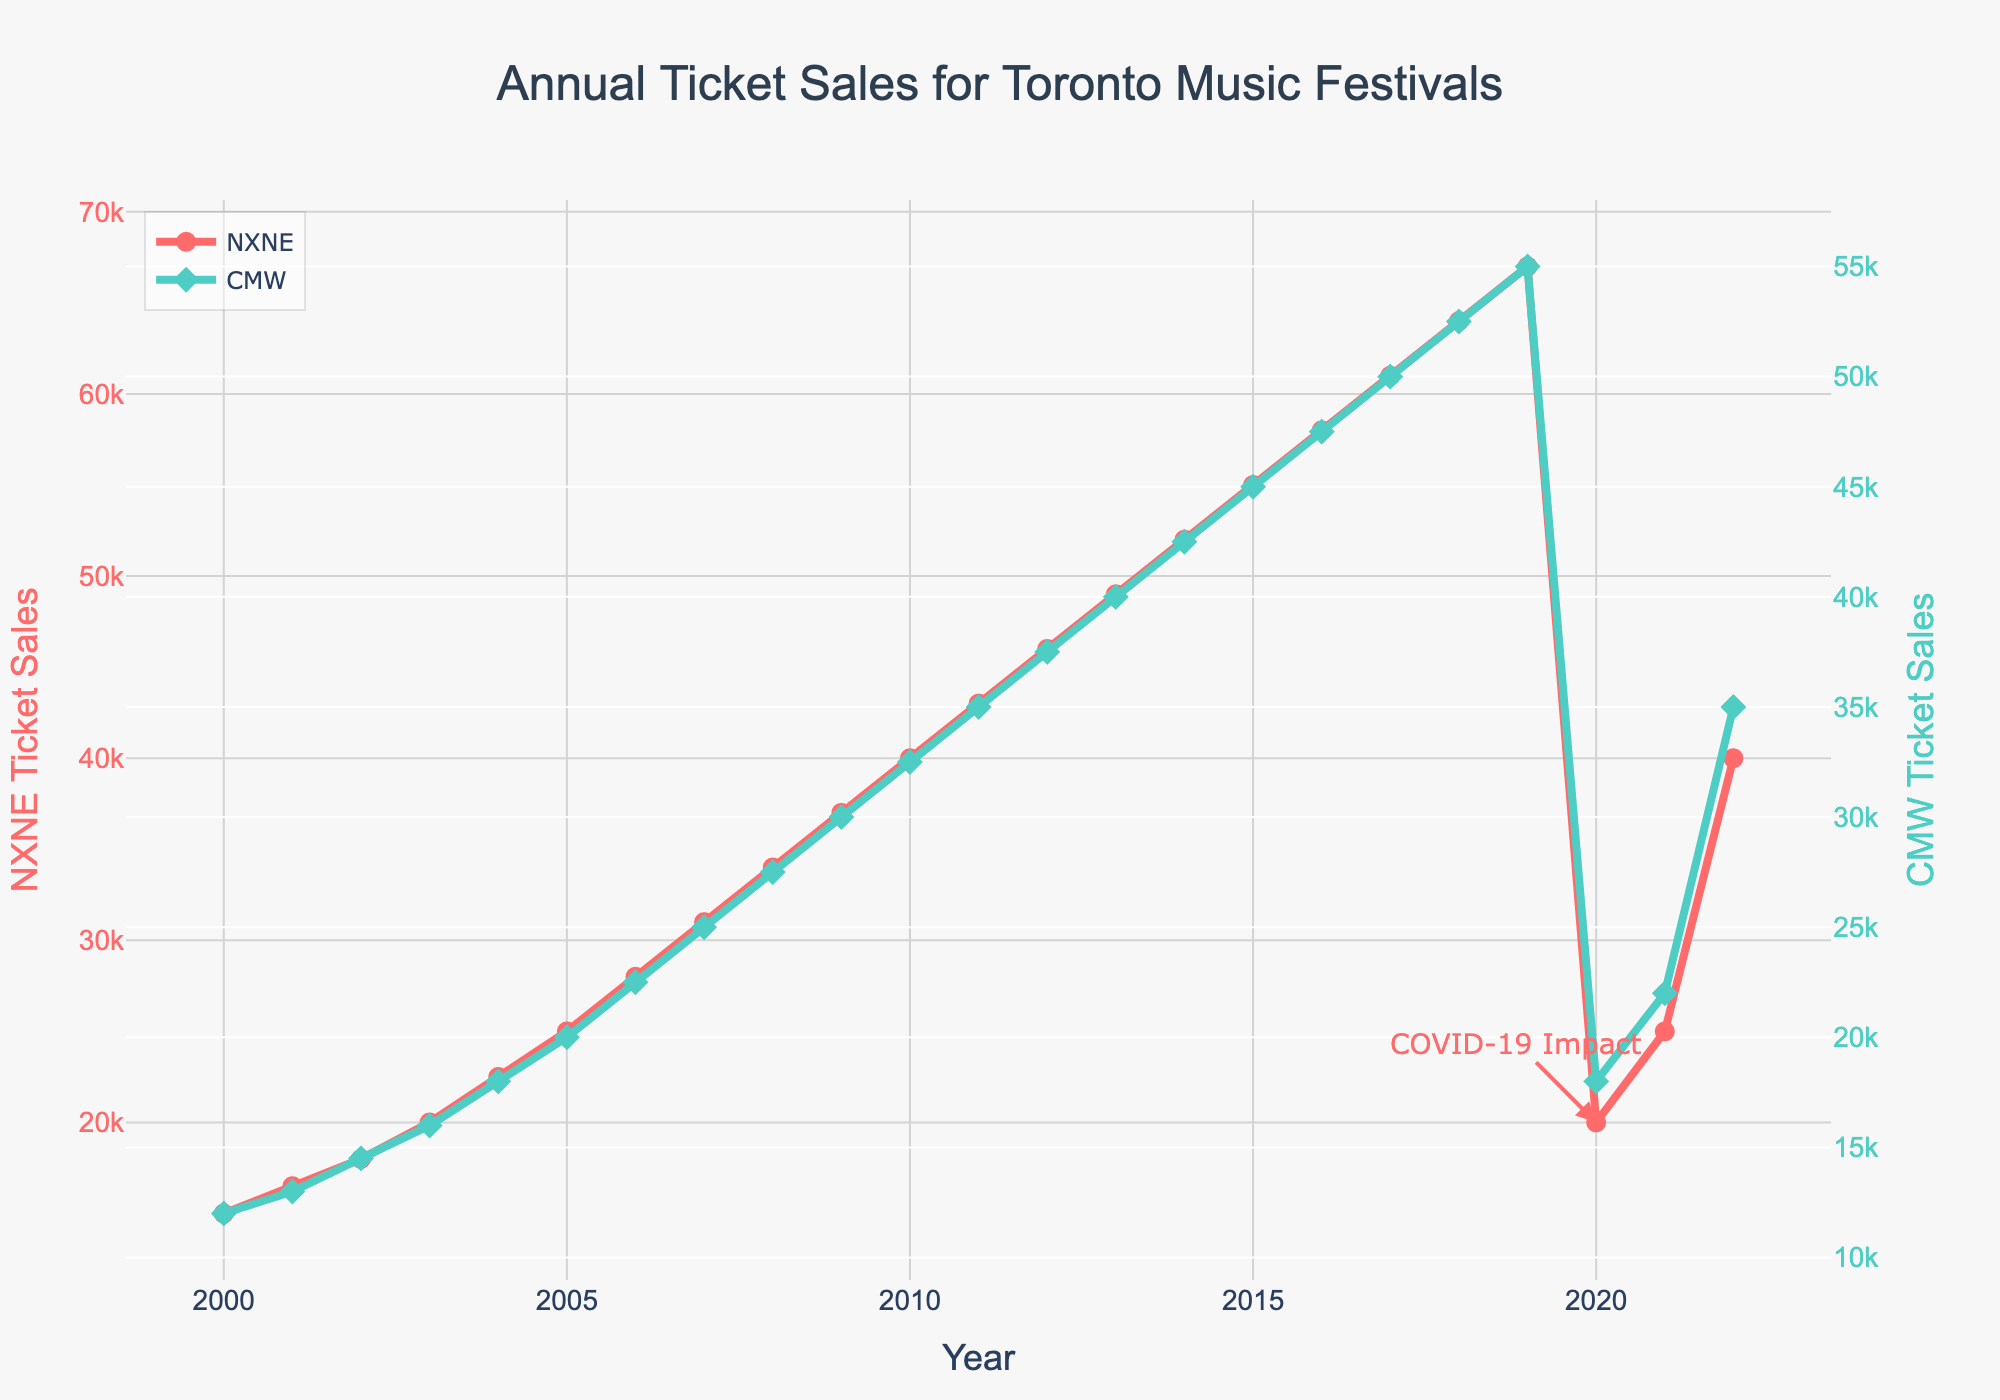Which year had the highest ticket sales for NXNE? Looking at the line representing NXNE ticket sales, the highest point on the graph corresponds to the year 2019.
Answer: 2019 What were the ticket sales for CMW in 2014? By checking the point on the CMW line that corresponds to the year 2014, we see it reaches 42,500 ticket sales.
Answer: 42,500 How did ticket sales for NXNE change between 2019 and 2020? The plot shows a steep decline from the highest point in 2019 (67,000) to a sharp drop in 2020 (20,000). Subtract 20,000 from 67,000 to find the change.
Answer: -47,000 What is the difference in ticket sales between NXNE and CMW in 2022? For 2022, NXNE has 40,000 ticket sales and CMW has 35,000. Subtract 35,000 from 40,000 to get the difference.
Answer: 5,000 Which festival experienced a greater drop in ticket sales from 2019 to 2020? Compare the difference between NXNE and CMW ticket sales from 2019 to 2020. NXNE dropped from 67,000 to 20,000, a decrease of 47,000, while CMW dropped from 55,000 to 18,000, a decrease of 37,000.
Answer: NXNE How many years did NXNE have ticket sales above 40,000? By counting the periods where the NXNE line is above the 40,000 mark, from 2010 to 2019, we get a total of 10 years.
Answer: 10 What is the average ticket sales for CMW between 2005 and 2010? Identifying CMW sales for each year from 2005 to 2010 and computing their sum (20,000 + 22,500 + 25,000 + 27,500 + 30,000 + 32,500 = 157,500) and then dividing by 6.
Answer: 26,250 Did either festival see an increase in ticket sales every year from 2000 to 2009? By analyzing both the NXNE and CMW lines from 2000 to 2009, we can see that both had a consistent increase in ticket sales every year during this period.
Answer: Yes What visual cue indicates the impact of COVID-19 on ticket sales? The annotation "COVID-19 Impact" is placed at the year 2020, tied to a significant drop in ticket sales for both festivals.
Answer: Annotation and drop in sales How much did NXNE ticket sales recover by 2022 from their low in 2020? From the data, NXNE ticket sales were 20,000 in 2020 and rose to 40,000 in 2022. Subtract 20,000 from 40,000.
Answer: 20,000 